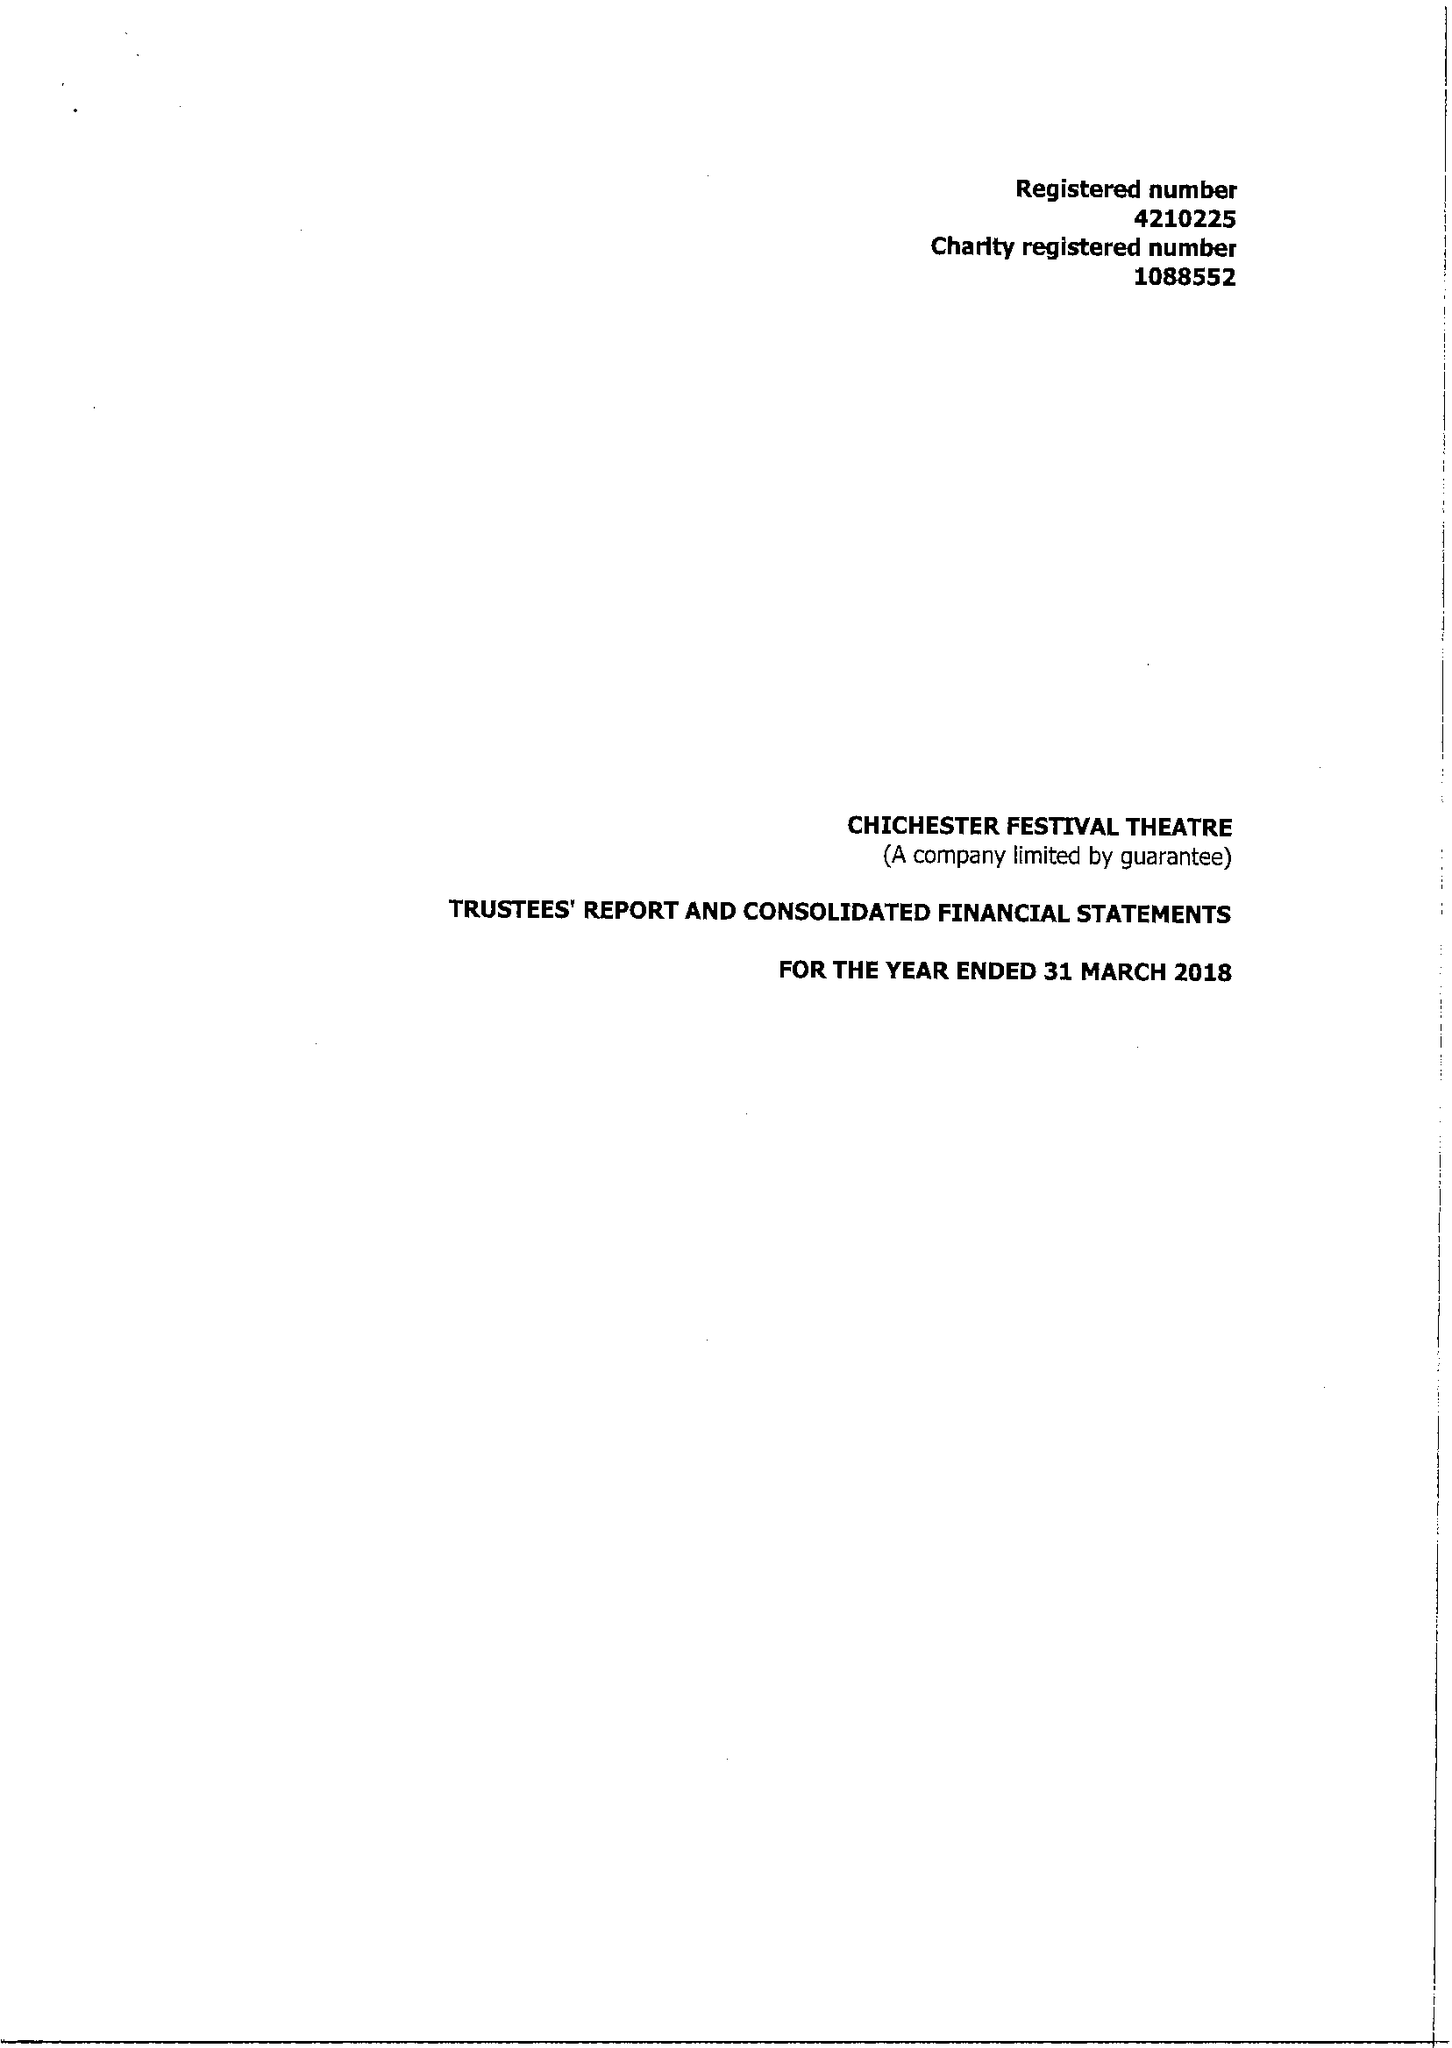What is the value for the address__postcode?
Answer the question using a single word or phrase. PO19 6AP 